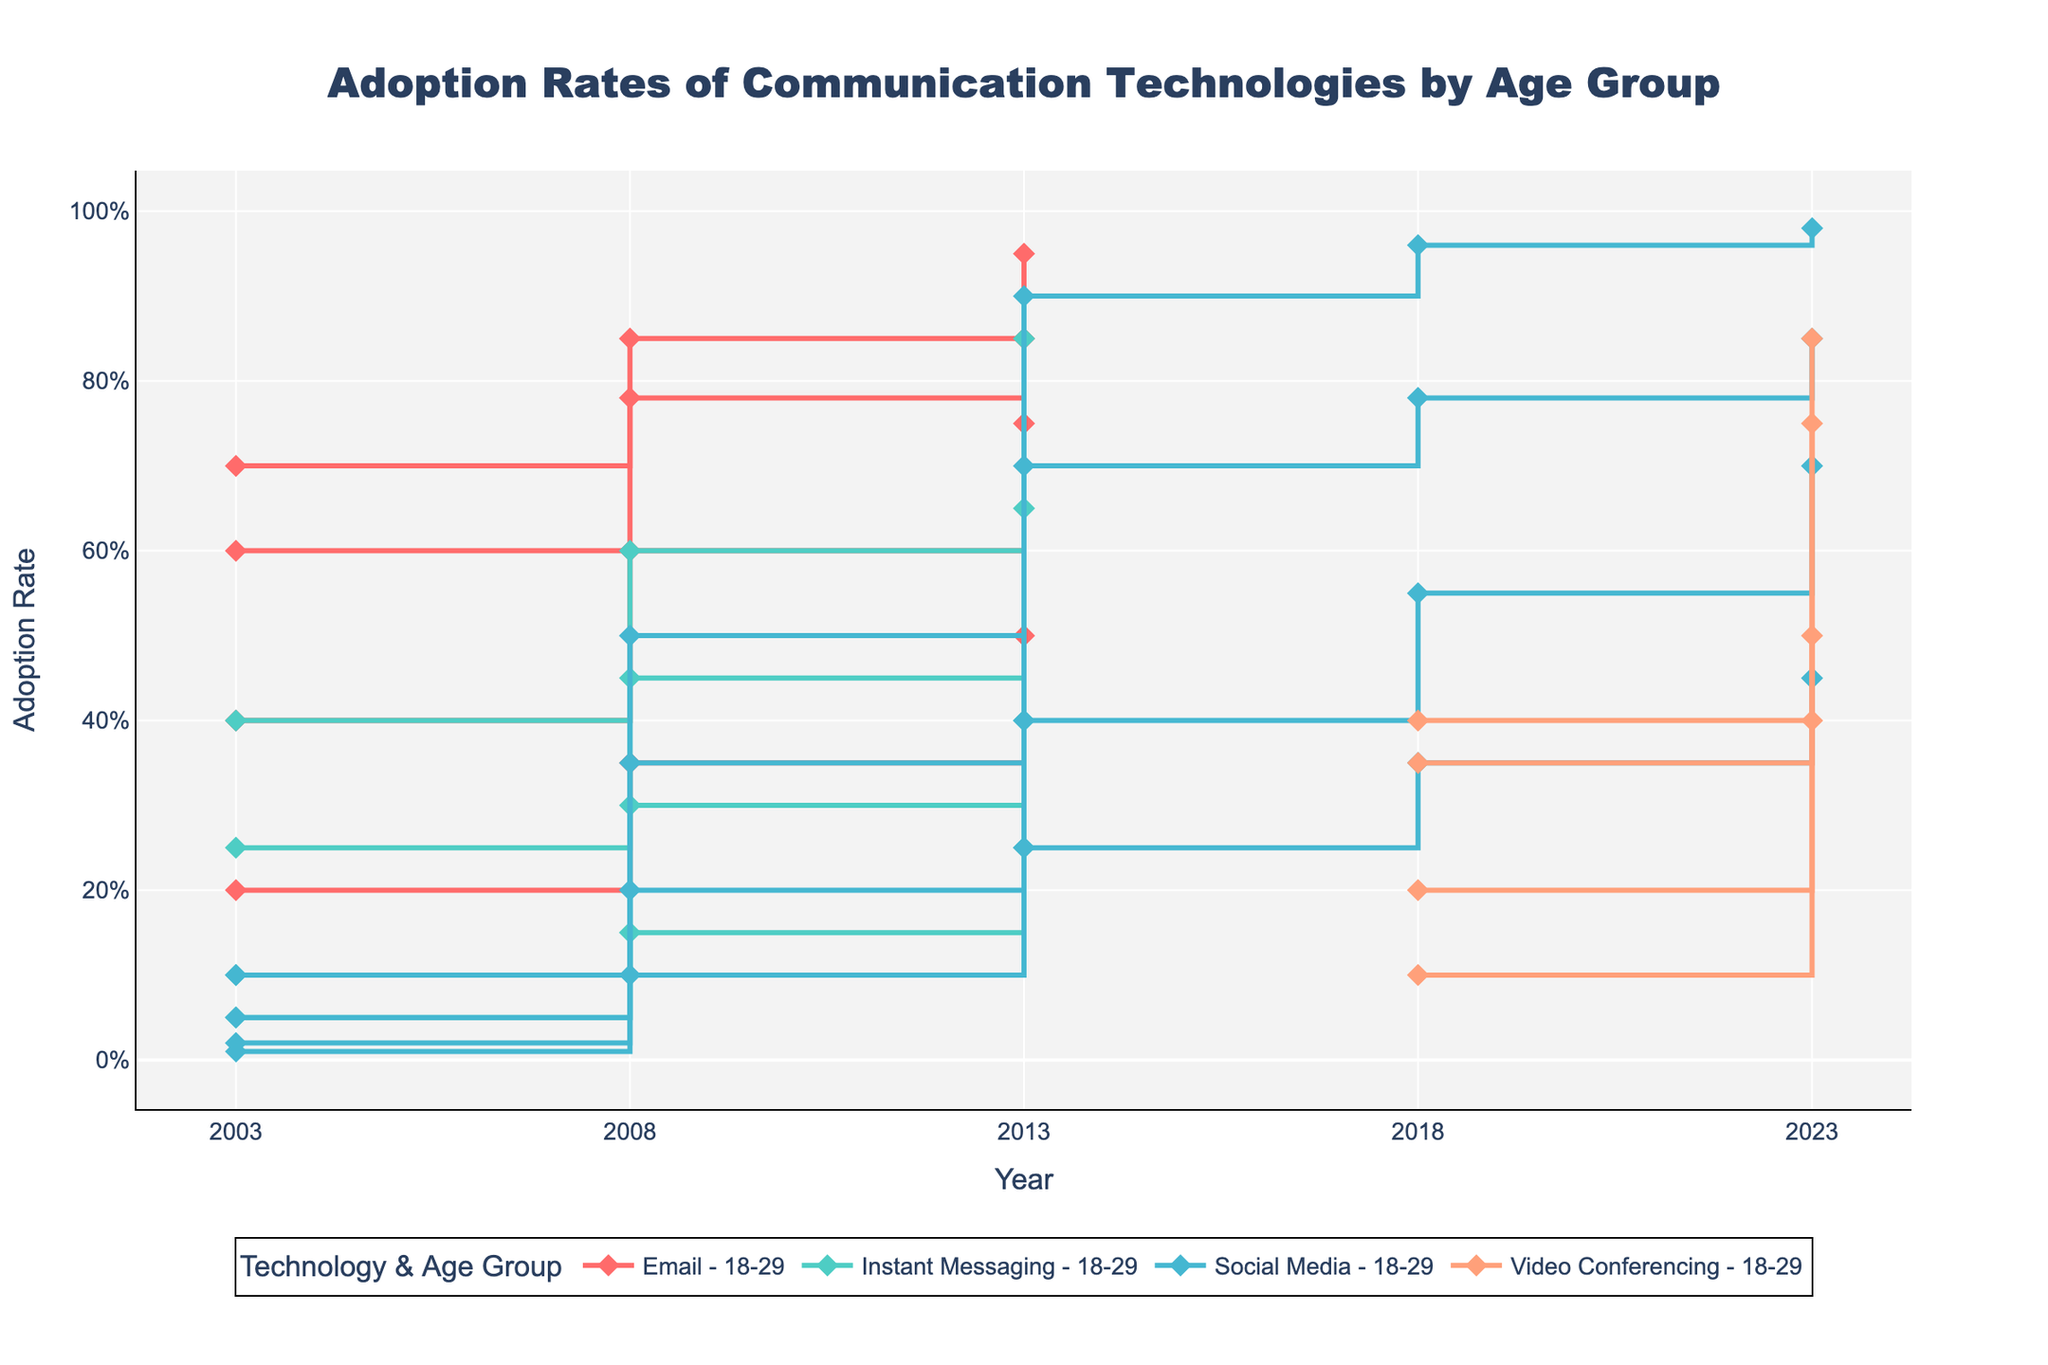What is the adoption rate of Social Media among the 18-29 age group in 2023? Locate the 2023 data point for Social Media and the 18-29 age group on the stair plot. The corresponding Y-axis value gives the adoption rate.
Answer: 98% Which technology had the highest adoption rate among the 65+ age group in 2018? Compare the plot lines representing different technologies for the 65+ age group in 2018. The highest Y-axis value indicates the technology with the highest adoption rate.
Answer: Social Media By how much did the adoption rate of Video Conferencing for the 30-49 age group increase from 2018 to 2023? Identify the adoption rates of Video Conferencing for the 30-49 age group in 2018 and 2023 from the plot. Subtract the 2018 rate from the 2023 rate.
Answer: 40% What is the average adoption rate of Instant Messaging for the 50-64 age group from 2003 to 2013? Find the adoption rates of Instant Messaging for the 50-64 age group in 2003, 2008, and 2013. Add these rates, then divide by 3.
Answer: 26.67% Which age group showed the most significant increase in email adoption from 2003 to 2008? Compare the differences in adoption rates for email from 2003 to 2008 across all age groups. The age group with the largest difference has the most significant increase.
Answer: 65+ In 2023, which communication technology had the smallest adoption rate difference between the 18-29 and 65+ age groups? For each technology in 2023, calculate the difference in adoption rates between the 18-29 and 65+ age groups by subtracting the rate for the 65+ group from the rate for the 18-29 group. Identify the smallest difference.
Answer: Video Conferencing Is there a technology where the 50-64 age group consistently lags behind the 18-29 age group between 2003 and 2018? For each technology, compare the adoption rates for the 50-64 and 18-29 age groups across the years 2003, 2008, and 2013. If, in each year, the rate for the 50-64 group is lower than that for the 18-29 group, the technology qualifies.
Answer: Yes, Social Media How did the adoption rates of Instant Messaging for the 30-49 age group change between 2003 and 2008? Look at the plot points for Instant Messaging and the 30-49 age group in 2003 and 2008. Note the values and state the change by subtracting the 2003 value from the 2008 value.
Answer: Increased by 20% Between 2003 and 2018, which technology saw the greatest increase in adoption rate for the 65+ age group? For each technology, calculate the increase in adoption rate for the 65+ age group by subtracting the 2003 value from the 2018 value. Compare the increases and determine the greatest one.
Answer: Social Media 